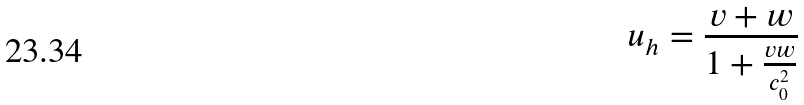Convert formula to latex. <formula><loc_0><loc_0><loc_500><loc_500>u _ { h } = \frac { v + w } { 1 + \frac { v w } { c _ { 0 } ^ { 2 } } }</formula> 